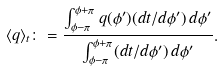<formula> <loc_0><loc_0><loc_500><loc_500>\langle q \rangle _ { t } \colon = \frac { \int _ { \phi - \pi } ^ { \phi + \pi } q ( \phi ^ { \prime } ) ( d t / d \phi ^ { \prime } ) \, d \phi ^ { \prime } } { \int _ { \phi - \pi } ^ { \phi + \pi } ( d t / d \phi ^ { \prime } ) \, d \phi ^ { \prime } } .</formula> 